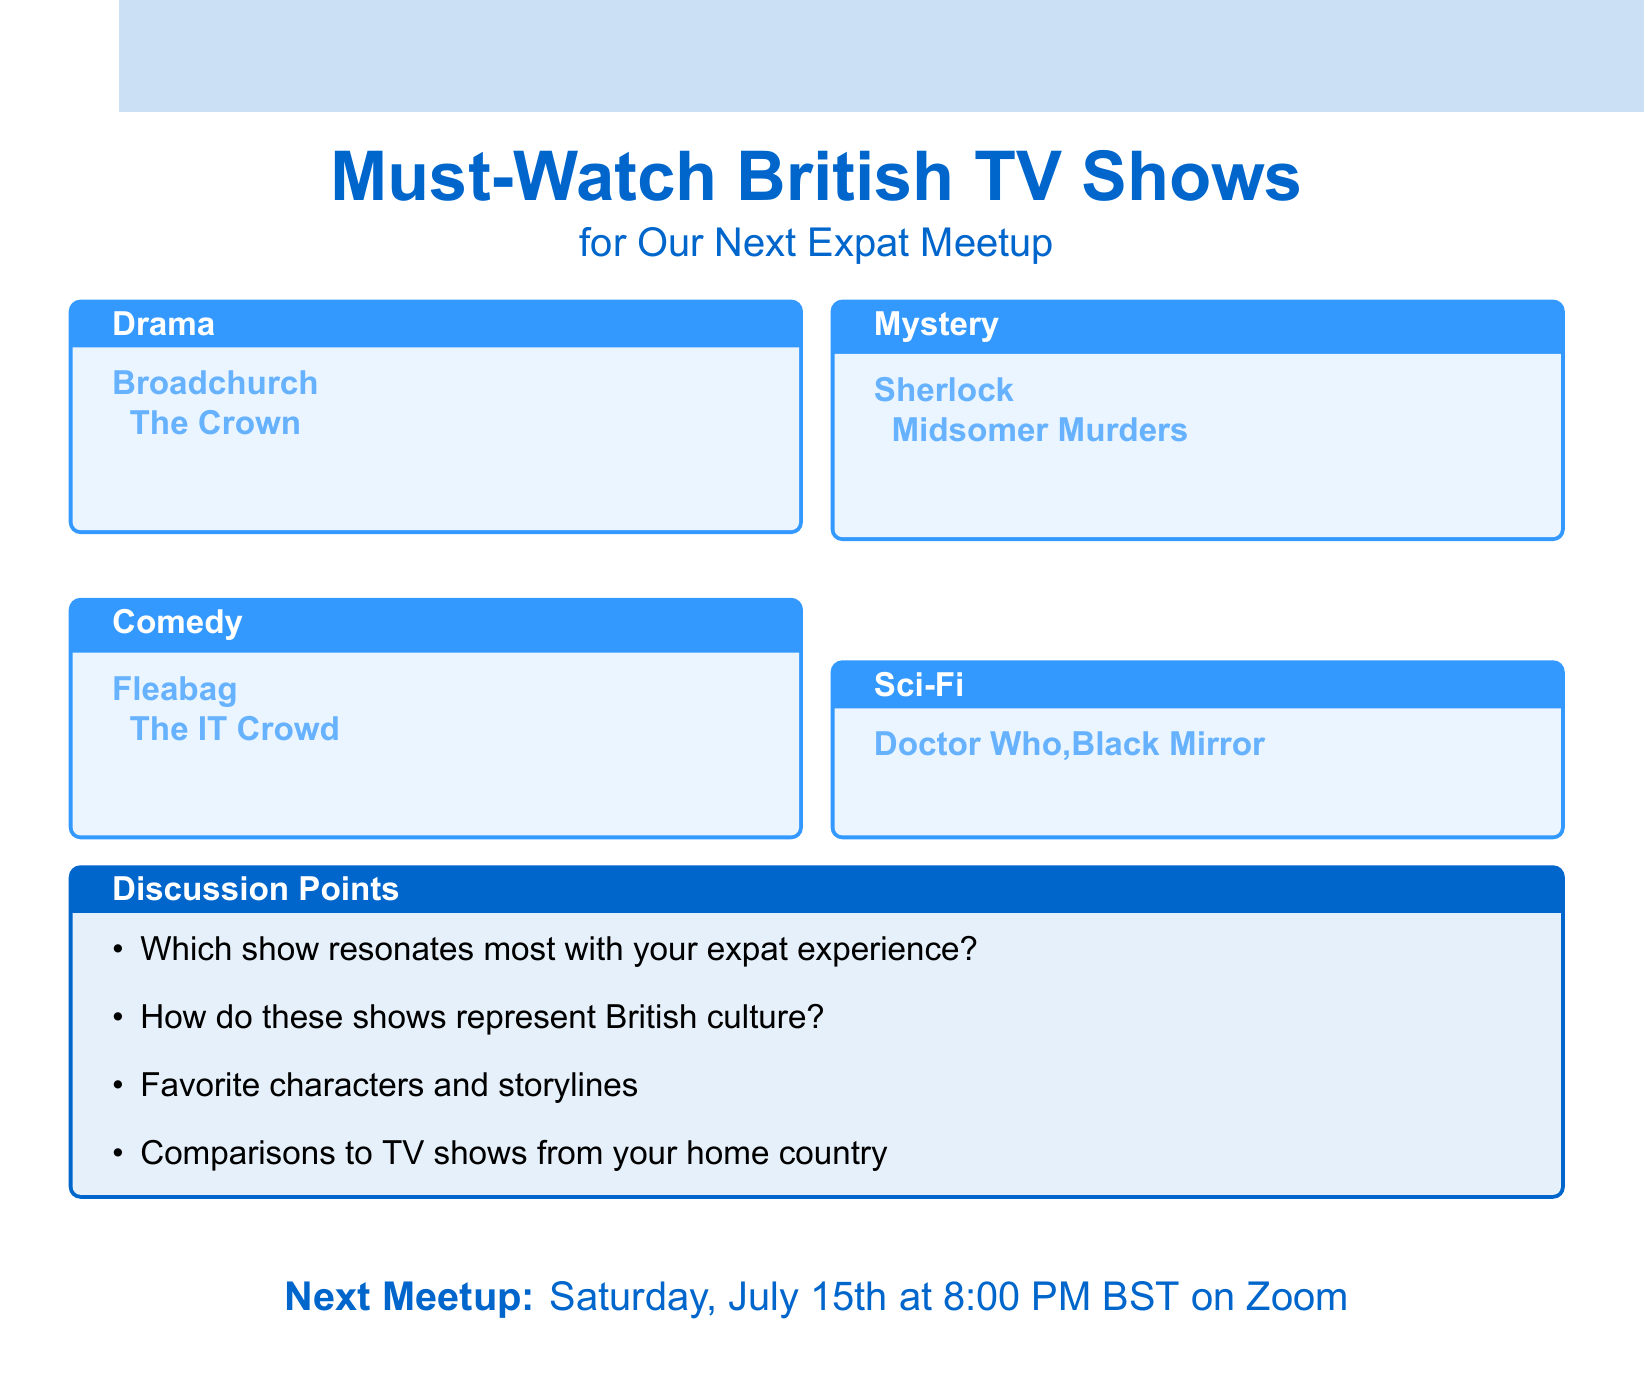What is the title of the document? The title is stated at the beginning of the document, indicating the content focus.
Answer: Must-Watch British TV Shows for Our Next Expat Meetup How many drama shows are listed? The number of drama shows is specified in the genres section of the document.
Answer: 2 Which streaming service has "Fleabag"? The streaming service for "Fleabag" is mentioned directly under its description in the comedy section.
Answer: Amazon Prime What is the date of the next meetup? The next meetup date is clearly stated towards the end of the document.
Answer: Saturday, July 15th Which show is described as a "long-running detective series"? The description provided under the mystery genre identifies the specific show.
Answer: Midsomer Murders How many genres are covered in the document? The count of genres is found by reviewing the categories listed in the document's structure.
Answer: 4 What is the description of "Doctor Who"? The description is provided directly under the show title in the sci-fi genre section.
Answer: Iconic time-traveling adventure series What platform will the next meetup be held on? The platform for the upcoming meetup is mentioned in the final section of the document.
Answer: Zoom Which show has the primary theme of technology? The document explicitly identifies the show related to technology under the sci-fi genre.
Answer: Black Mirror 